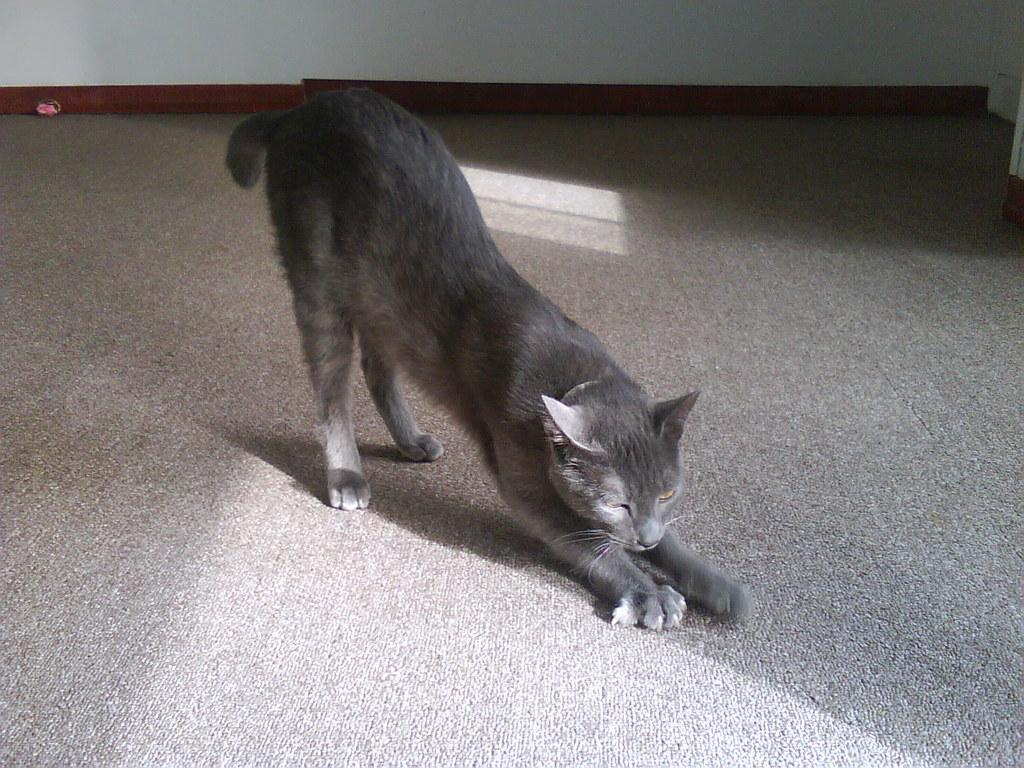Could you give a brief overview of what you see in this image? In this picture we can see a cat on the ground and in the background we can see a wall and some objects. 